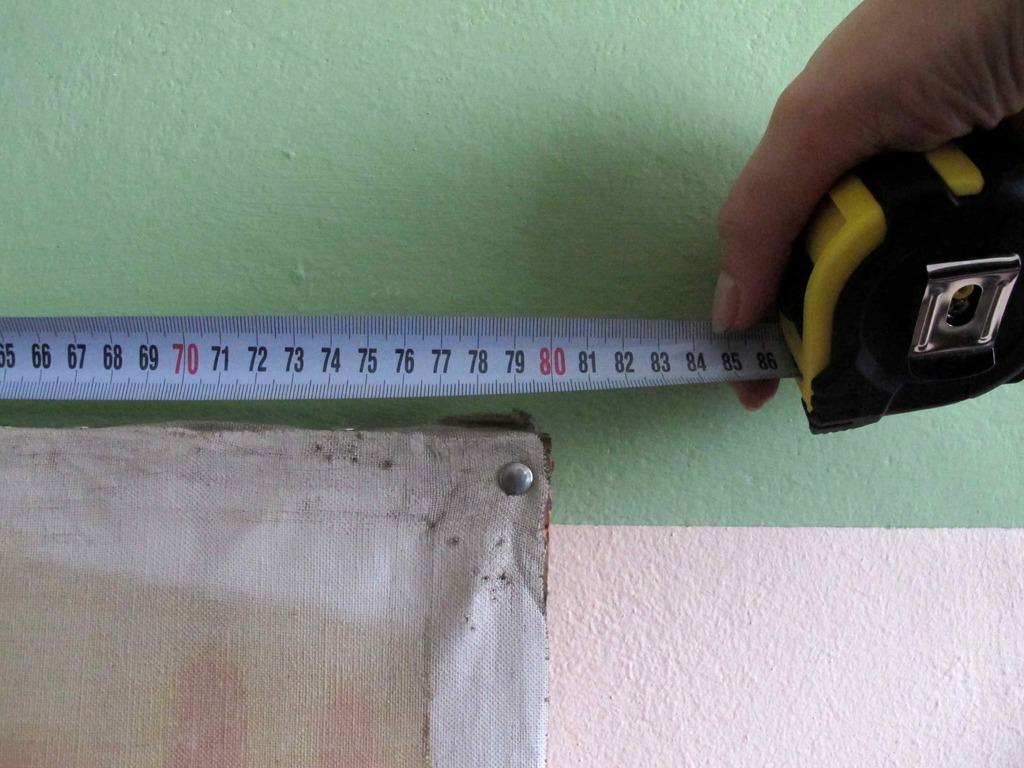What does the measurement read?
Your answer should be compact. 80. What is a red number on the measurement?
Make the answer very short. 80. 